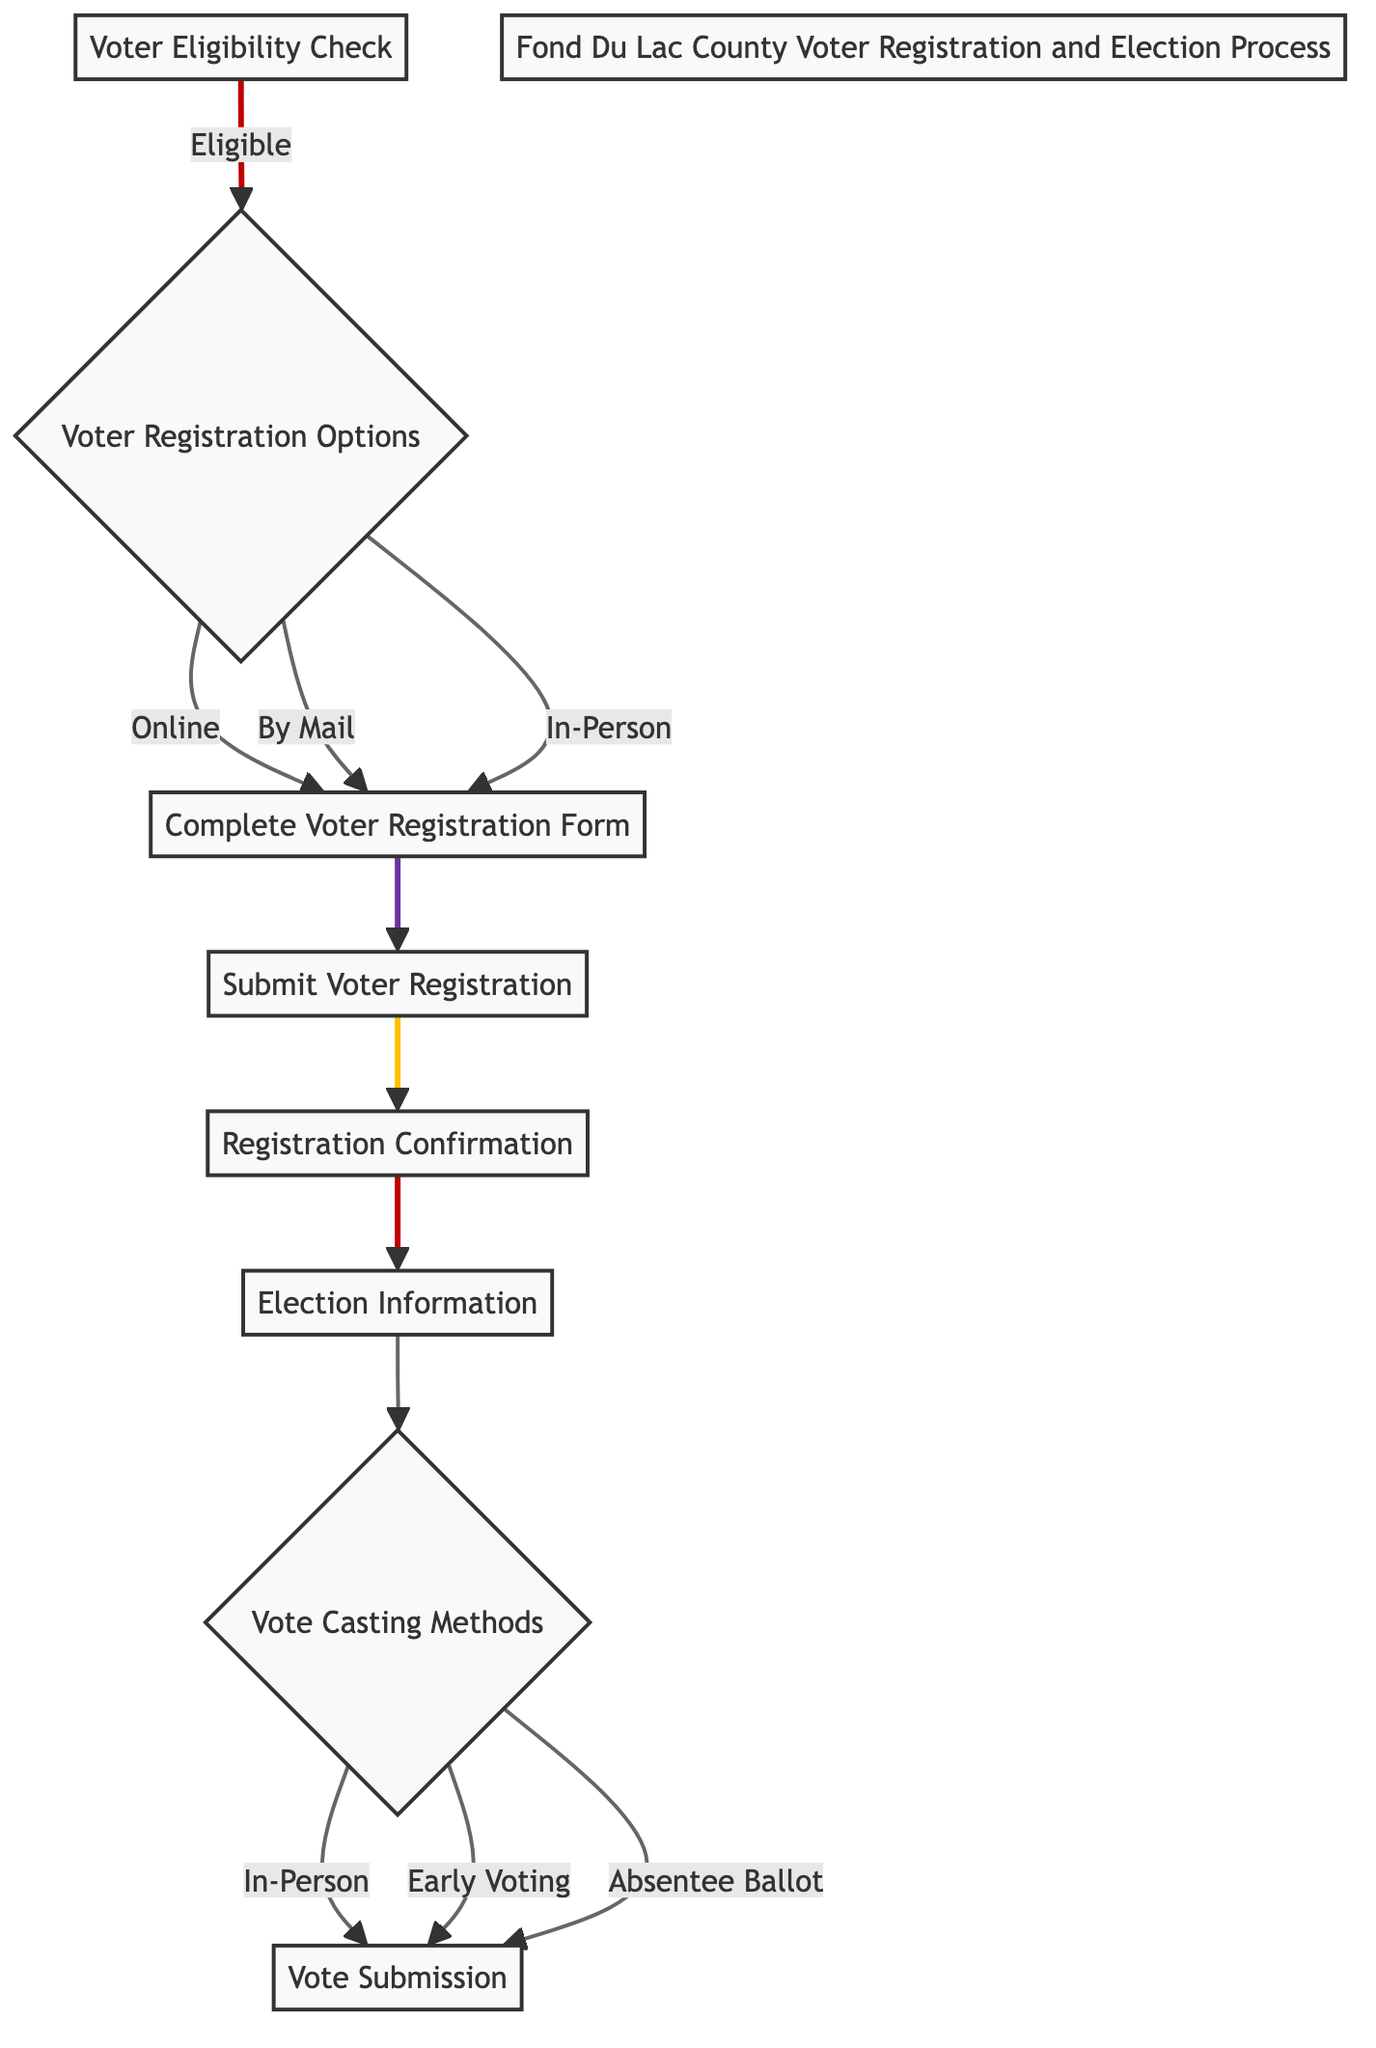What is the first step in the voter registration process? The diagram shows that the first step is "Voter Eligibility Check," which verifies that the individual meets the eligibility criteria such as age, citizenship, and residency.
Answer: Voter Eligibility Check How many ways are there to register to vote? In the diagram, the "Voter Registration Options" node branches into three alternatives: Online, By Mail, and In-Person, indicating three methods for voter registration.
Answer: Three What do you receive after submitting the voter registration? According to the diagram, after submitting the voter registration form, the next step is to receive "Registration Confirmation," indicating that you will be informed about your registration status.
Answer: Registration Confirmation What happens after receiving election information? The diagram shows that after obtaining "Election Information," the next decision point is "Vote Casting Methods," which means that individuals will then decide how to cast their vote based on the information they received.
Answer: Vote Casting Methods If someone chooses to vote by absentee ballot, what is the final step? In the flow chart, if a person selects "Absentee Ballot" under "Vote Casting Methods," the final step is "Vote Submission," which indicates that they will cast their vote and ensure it is counted.
Answer: Vote Submission How does one confirm their voter registration status? The "Registration Confirmation" node in the diagram suggests that after submitting the registration form, confirmation of voter registration status is received from the Clerk's office, giving assurance of registration.
Answer: From the Clerk's office What are the three methods listed for casting a vote? The diagram's "Vote Casting Methods" node shows three options branching out: In-Person, Early Voting, and Absentee Ballot, indicating the various ways a voter can cast their vote.
Answer: In-Person, Early Voting, Absentee Ballot What step follows after "Complete Voter Registration Form"? The diagram indicates that after completing the voter registration form, the next step is "Submit Voter Registration," where the individual sends the completed form to the Clerk's office to finalize the registration process.
Answer: Submit Voter Registration 